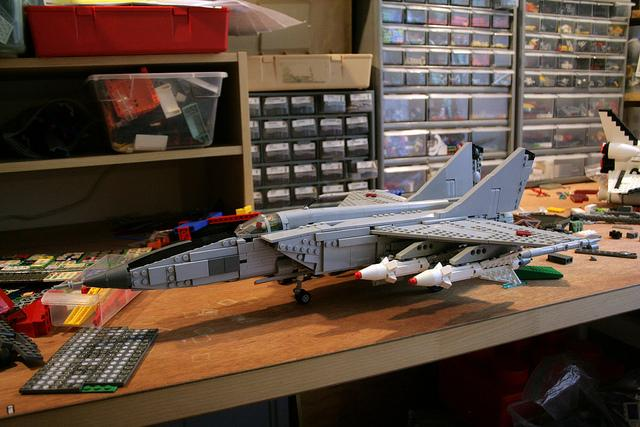What was used to build this plane?

Choices:
A) metal
B) paper
C) plastic
D) legos legos 